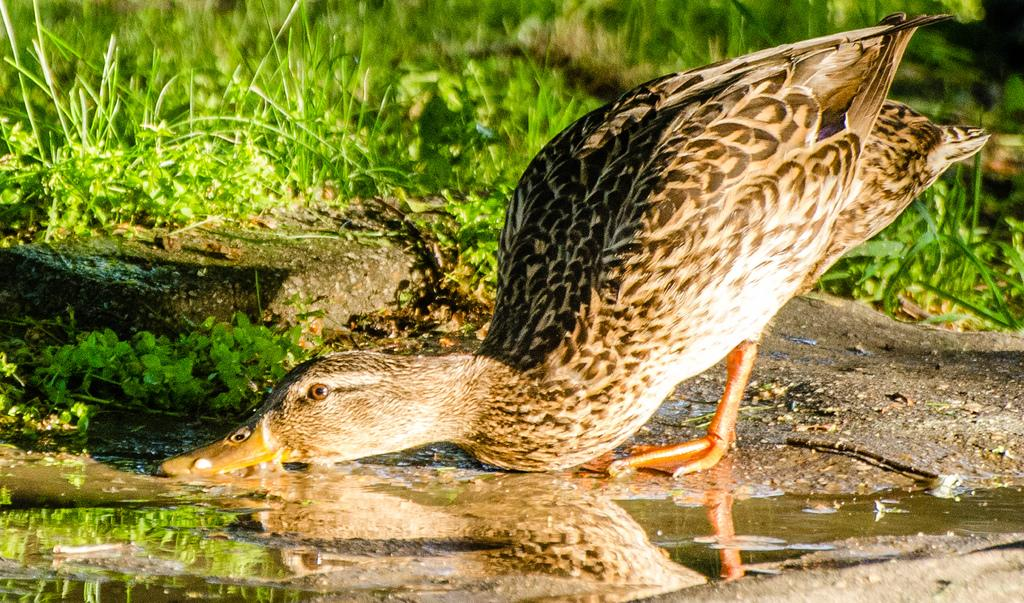What animal is present in the image? There is a duck in the picture. What is at the bottom of the picture? There is water at the bottom of the picture. What can be seen in the background of the image? There are plants visible in the background of the picture. What type of relation does the duck have with the toe in the image? There is no toe present in the image, so the duck cannot have any relation with it. 